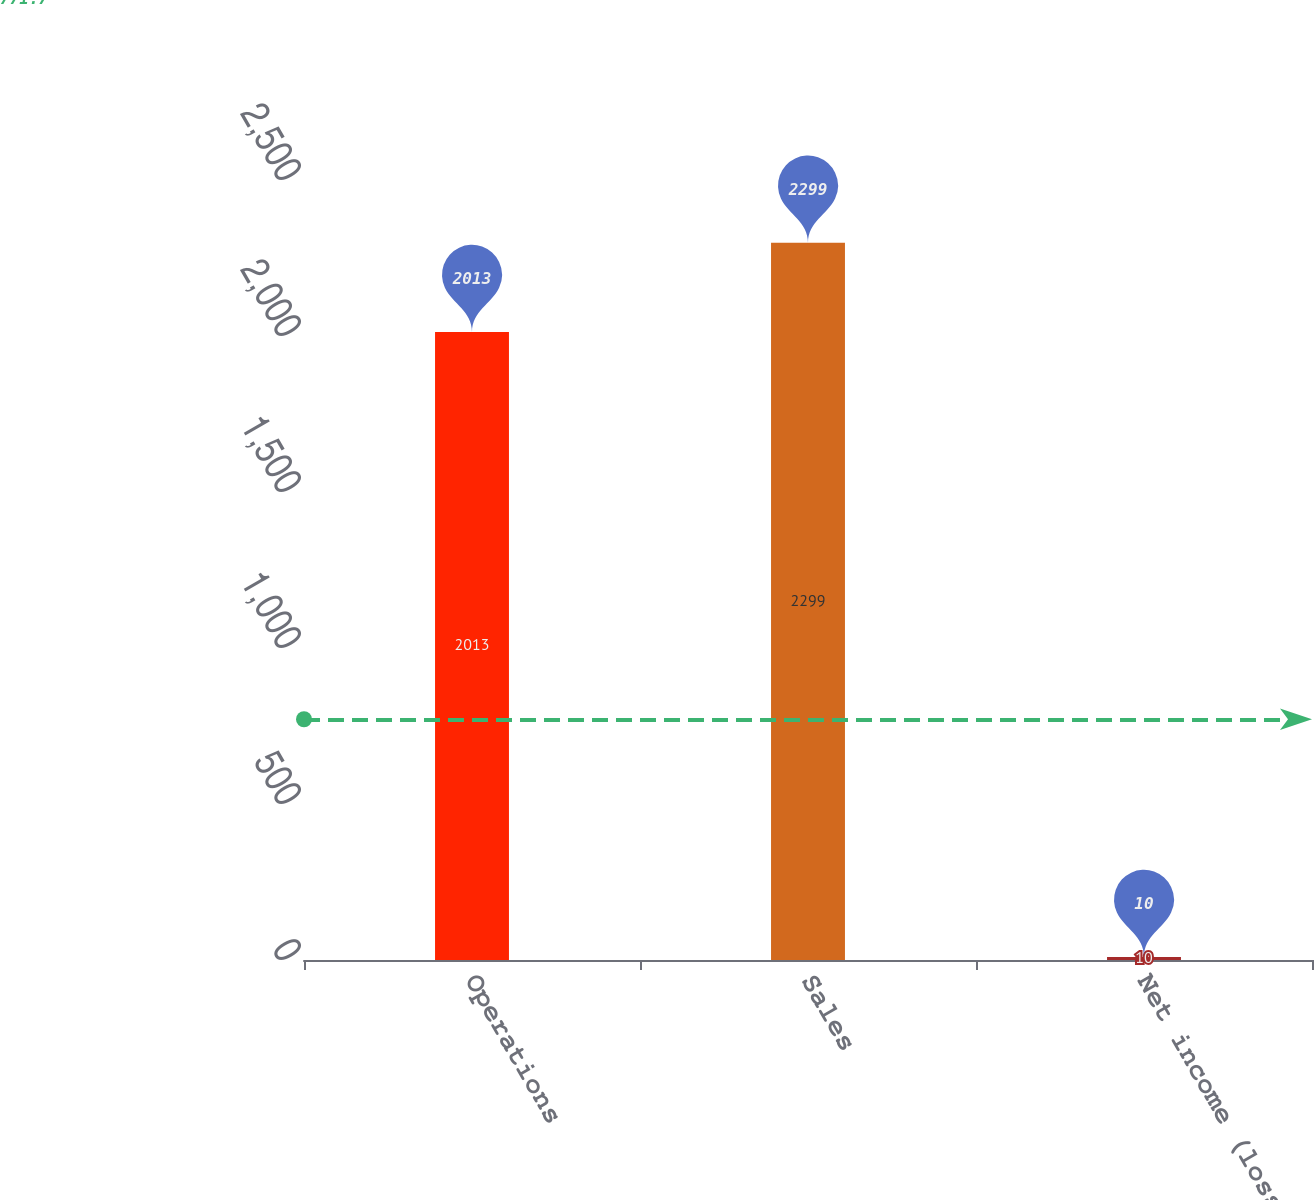<chart> <loc_0><loc_0><loc_500><loc_500><bar_chart><fcel>Operations<fcel>Sales<fcel>Net income (loss)<nl><fcel>2013<fcel>2299<fcel>10<nl></chart> 